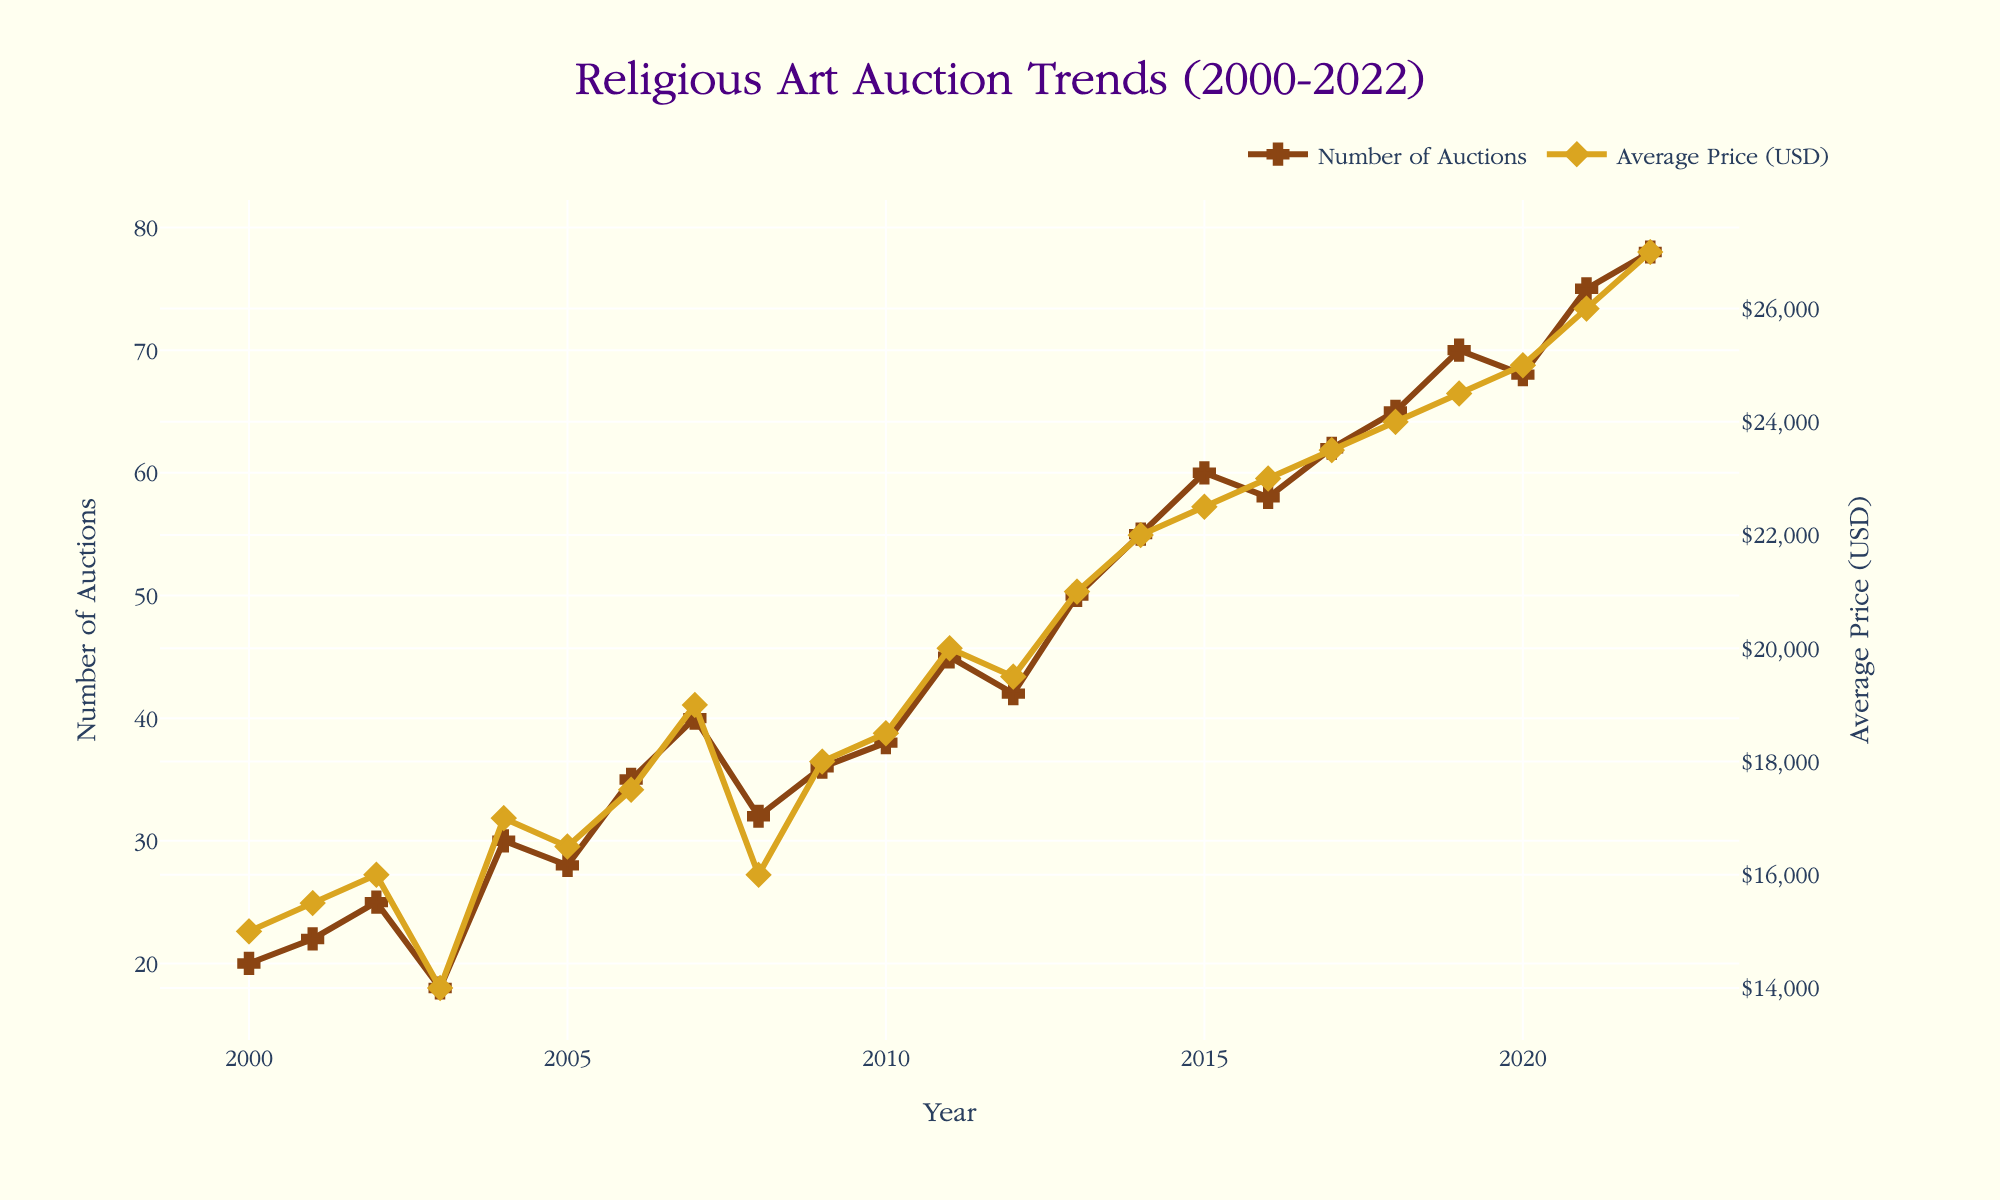What is the title of the figure? The title of the figure is usually placed at the top and provides a concise description of the content. Here, the title reads "Religious Art Auction Trends (2000-2022)."
Answer: Religious Art Auction Trends (2000-2022) What are the two y-axes measuring? Looking at the labels on each side of the figure, the left y-axis measures the "Number of Auctions," and the right y-axis measures the "Average Price (USD)."
Answer: Number of Auctions, Average Price (USD) Which year had the highest average price, and what was that price? From the right y-axis curve, the year with the highest average price is 2022. The corresponding price can be read from the scale and hover information, which is $27,000.
Answer: 2022, $27,000 How did the number of auctions change from 2000 to 2022? By following the trend line on the left y-axis, you can see that the number of auctions increased from 20 in 2000 to 78 in 2022.
Answer: Increased from 20 to 78 In which year did the number of auctions first exceed 50? Looking at the left y-axis, the number of auctions first exceeds 50 in the year 2014.
Answer: 2014 Compare the average price of religious art in 2010 to that in 2005. Using the right y-axis, observe that the average price in 2010 was $18,500, while in 2005 it was $16,500.
Answer: $18,500 (2010) vs. $16,500 (2005) Between which consecutive years did the number of auctions increase the most? By analyzing the line on the left y-axis, the largest increase occurs between 2021 and 2022, going from 75 to 78 auctions.
Answer: 2021 to 2022 What was the overall trend in average price from 2000 to 2022? Observing the right y-axis, there is a general upward trend in the average price from $15,000 in 2000 to $27,000 in 2022.
Answer: Upward trend During which years did the average price decrease? Based on the right y-axis curve, the average price decreased in the years 2003 and 2008.
Answer: 2003, 2008 What is the largest price increase observed between two consecutive years, and when did it occur? By examining the right y-axis, the largest increase occurs between 2021 and 2022, where the price increases from $26,000 to $27,000.
Answer: $1,000, 2021 to 2022 